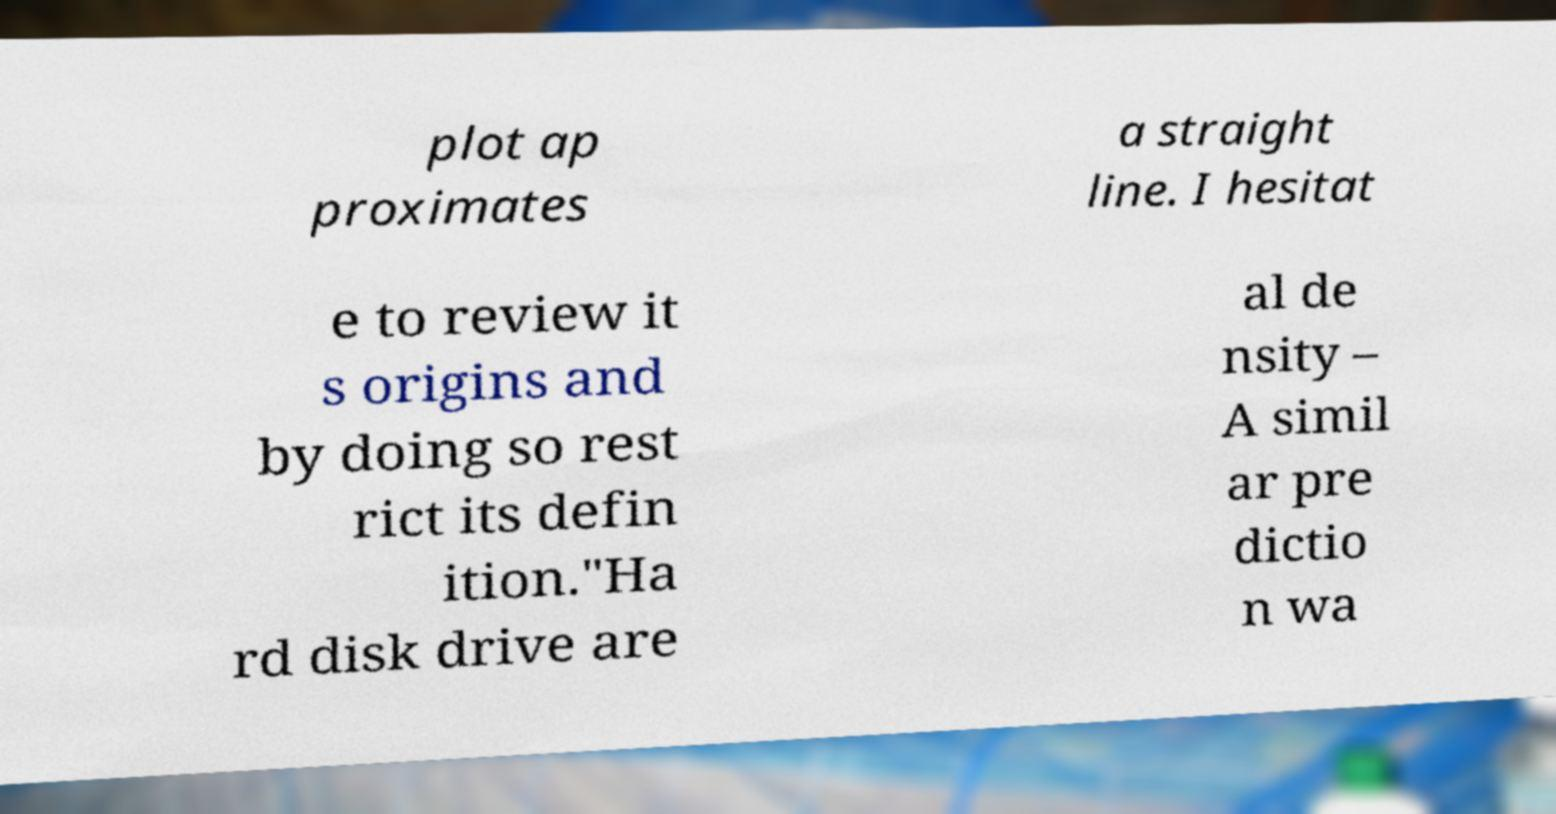For documentation purposes, I need the text within this image transcribed. Could you provide that? plot ap proximates a straight line. I hesitat e to review it s origins and by doing so rest rict its defin ition."Ha rd disk drive are al de nsity – A simil ar pre dictio n wa 